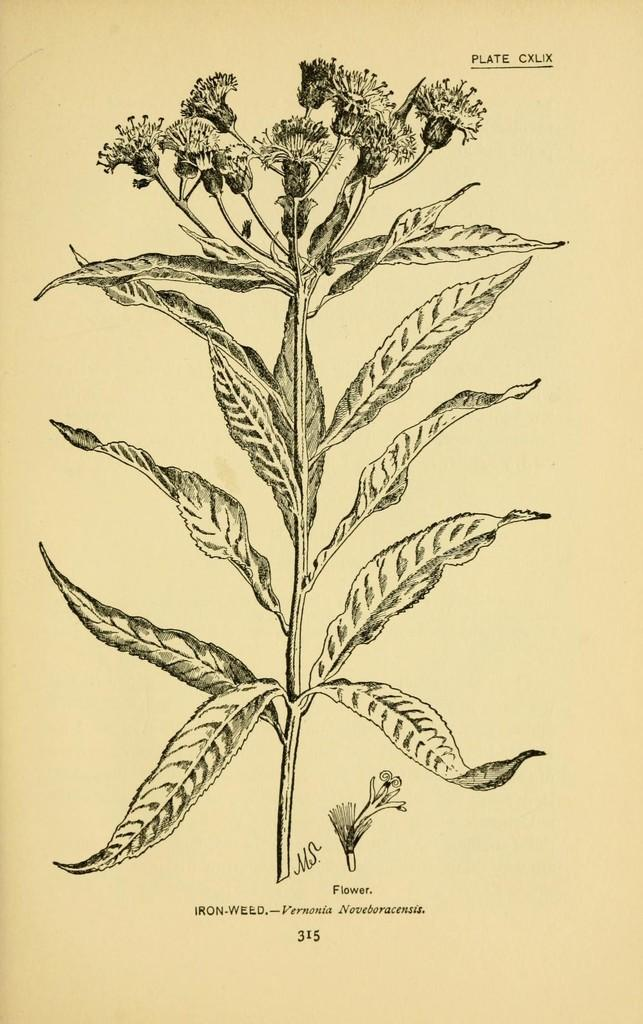What is the main subject of the image? The main subject of the image is a plant with flowers diagram. What is the diagram drawn on? The diagram is drawn on a paper. How many marbles are present in the image? There are no marbles present in the image; it features a plant with flowers diagram on a paper. What direction is the frog facing in the image? There is no frog present in the image. 